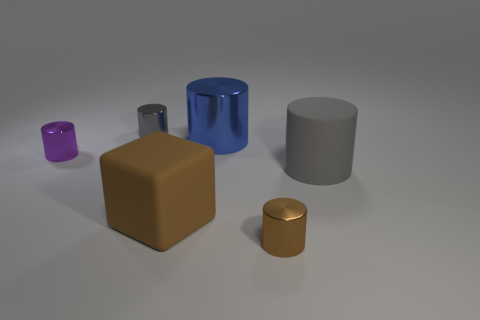Add 3 tiny purple matte cylinders. How many objects exist? 9 Subtract all large cylinders. How many cylinders are left? 3 Subtract all yellow cubes. How many gray cylinders are left? 2 Subtract 1 cylinders. How many cylinders are left? 4 Subtract all purple cylinders. How many cylinders are left? 4 Subtract all cylinders. How many objects are left? 1 Subtract all yellow cylinders. Subtract all brown balls. How many cylinders are left? 5 Subtract all gray metallic things. Subtract all large gray blocks. How many objects are left? 5 Add 2 big shiny objects. How many big shiny objects are left? 3 Add 1 purple things. How many purple things exist? 2 